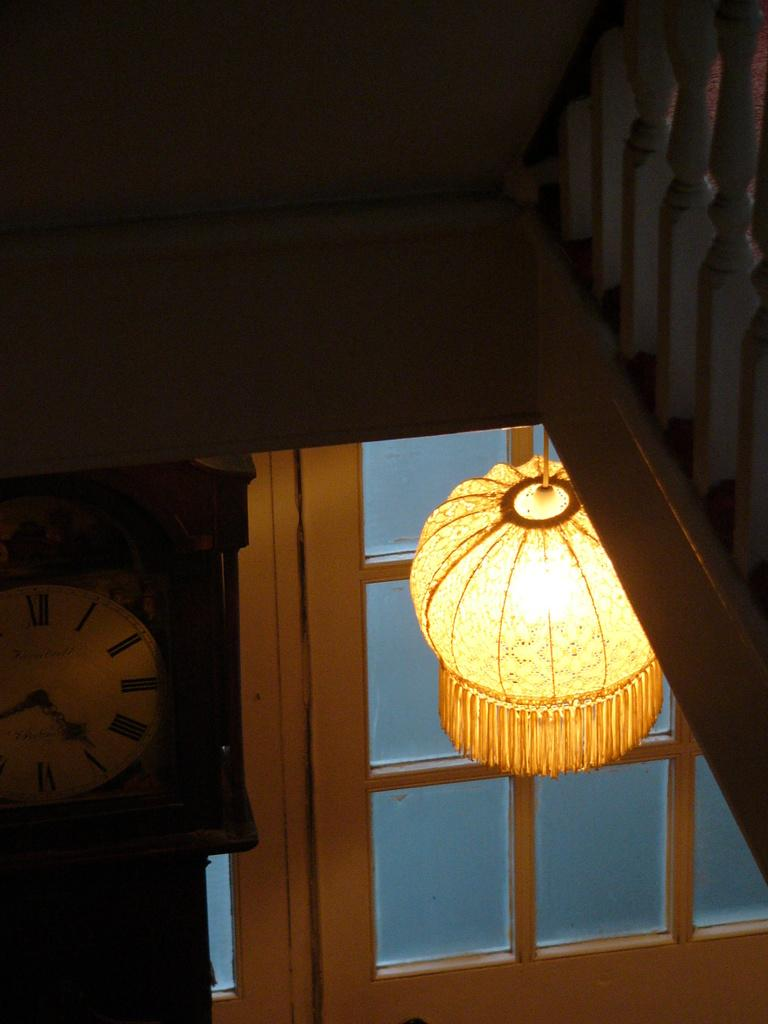What can be seen on the right side of the image? There is a railing on the right side of the image. What is located on the left side of the image? There is a clock on the left side of the image. What architectural feature is visible in the background of the image? There is a door in the background of the image. What is near the door in the background? There is a light near the door in the background. What type of book is lying on the floor in the image? There is no book present in the image. Is there a notebook visible on the table in the image? There is no notebook visible in the image. 